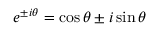Convert formula to latex. <formula><loc_0><loc_0><loc_500><loc_500>e ^ { \pm i \theta } = \cos \theta \pm i \sin \theta</formula> 